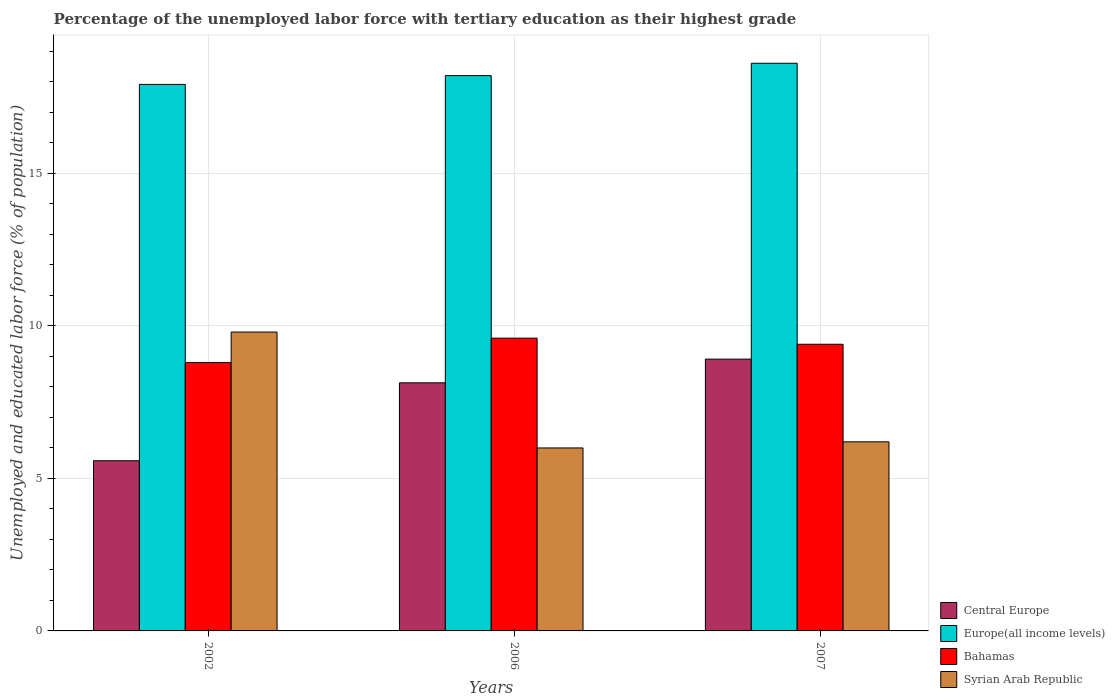How many groups of bars are there?
Offer a very short reply. 3. Are the number of bars on each tick of the X-axis equal?
Your answer should be very brief. Yes. How many bars are there on the 2nd tick from the left?
Your response must be concise. 4. What is the label of the 3rd group of bars from the left?
Provide a short and direct response. 2007. In how many cases, is the number of bars for a given year not equal to the number of legend labels?
Offer a terse response. 0. What is the percentage of the unemployed labor force with tertiary education in Syrian Arab Republic in 2002?
Your response must be concise. 9.8. Across all years, what is the maximum percentage of the unemployed labor force with tertiary education in Central Europe?
Give a very brief answer. 8.91. Across all years, what is the minimum percentage of the unemployed labor force with tertiary education in Central Europe?
Your response must be concise. 5.58. In which year was the percentage of the unemployed labor force with tertiary education in Bahamas maximum?
Provide a short and direct response. 2006. What is the total percentage of the unemployed labor force with tertiary education in Bahamas in the graph?
Provide a succinct answer. 27.8. What is the difference between the percentage of the unemployed labor force with tertiary education in Syrian Arab Republic in 2002 and that in 2007?
Ensure brevity in your answer.  3.6. What is the difference between the percentage of the unemployed labor force with tertiary education in Central Europe in 2006 and the percentage of the unemployed labor force with tertiary education in Europe(all income levels) in 2002?
Give a very brief answer. -9.78. What is the average percentage of the unemployed labor force with tertiary education in Central Europe per year?
Give a very brief answer. 7.54. In the year 2007, what is the difference between the percentage of the unemployed labor force with tertiary education in Europe(all income levels) and percentage of the unemployed labor force with tertiary education in Bahamas?
Your answer should be very brief. 9.21. What is the ratio of the percentage of the unemployed labor force with tertiary education in Central Europe in 2002 to that in 2006?
Your answer should be very brief. 0.69. Is the difference between the percentage of the unemployed labor force with tertiary education in Europe(all income levels) in 2002 and 2006 greater than the difference between the percentage of the unemployed labor force with tertiary education in Bahamas in 2002 and 2006?
Offer a terse response. Yes. What is the difference between the highest and the second highest percentage of the unemployed labor force with tertiary education in Europe(all income levels)?
Keep it short and to the point. 0.41. What is the difference between the highest and the lowest percentage of the unemployed labor force with tertiary education in Europe(all income levels)?
Make the answer very short. 0.69. What does the 2nd bar from the left in 2007 represents?
Your answer should be very brief. Europe(all income levels). What does the 1st bar from the right in 2002 represents?
Ensure brevity in your answer.  Syrian Arab Republic. Is it the case that in every year, the sum of the percentage of the unemployed labor force with tertiary education in Syrian Arab Republic and percentage of the unemployed labor force with tertiary education in Europe(all income levels) is greater than the percentage of the unemployed labor force with tertiary education in Bahamas?
Give a very brief answer. Yes. How many years are there in the graph?
Offer a very short reply. 3. What is the title of the graph?
Provide a succinct answer. Percentage of the unemployed labor force with tertiary education as their highest grade. Does "North America" appear as one of the legend labels in the graph?
Offer a very short reply. No. What is the label or title of the Y-axis?
Keep it short and to the point. Unemployed and educated labor force (% of population). What is the Unemployed and educated labor force (% of population) of Central Europe in 2002?
Your answer should be very brief. 5.58. What is the Unemployed and educated labor force (% of population) in Europe(all income levels) in 2002?
Give a very brief answer. 17.92. What is the Unemployed and educated labor force (% of population) of Bahamas in 2002?
Make the answer very short. 8.8. What is the Unemployed and educated labor force (% of population) of Syrian Arab Republic in 2002?
Offer a very short reply. 9.8. What is the Unemployed and educated labor force (% of population) of Central Europe in 2006?
Your response must be concise. 8.14. What is the Unemployed and educated labor force (% of population) of Europe(all income levels) in 2006?
Make the answer very short. 18.21. What is the Unemployed and educated labor force (% of population) in Bahamas in 2006?
Offer a terse response. 9.6. What is the Unemployed and educated labor force (% of population) of Syrian Arab Republic in 2006?
Give a very brief answer. 6. What is the Unemployed and educated labor force (% of population) in Central Europe in 2007?
Your answer should be compact. 8.91. What is the Unemployed and educated labor force (% of population) in Europe(all income levels) in 2007?
Make the answer very short. 18.61. What is the Unemployed and educated labor force (% of population) of Bahamas in 2007?
Give a very brief answer. 9.4. What is the Unemployed and educated labor force (% of population) of Syrian Arab Republic in 2007?
Give a very brief answer. 6.2. Across all years, what is the maximum Unemployed and educated labor force (% of population) in Central Europe?
Ensure brevity in your answer.  8.91. Across all years, what is the maximum Unemployed and educated labor force (% of population) of Europe(all income levels)?
Your answer should be compact. 18.61. Across all years, what is the maximum Unemployed and educated labor force (% of population) of Bahamas?
Make the answer very short. 9.6. Across all years, what is the maximum Unemployed and educated labor force (% of population) of Syrian Arab Republic?
Provide a short and direct response. 9.8. Across all years, what is the minimum Unemployed and educated labor force (% of population) in Central Europe?
Keep it short and to the point. 5.58. Across all years, what is the minimum Unemployed and educated labor force (% of population) in Europe(all income levels)?
Offer a very short reply. 17.92. Across all years, what is the minimum Unemployed and educated labor force (% of population) in Bahamas?
Your answer should be compact. 8.8. Across all years, what is the minimum Unemployed and educated labor force (% of population) in Syrian Arab Republic?
Offer a very short reply. 6. What is the total Unemployed and educated labor force (% of population) in Central Europe in the graph?
Offer a very short reply. 22.63. What is the total Unemployed and educated labor force (% of population) of Europe(all income levels) in the graph?
Make the answer very short. 54.74. What is the total Unemployed and educated labor force (% of population) of Bahamas in the graph?
Your response must be concise. 27.8. What is the difference between the Unemployed and educated labor force (% of population) of Central Europe in 2002 and that in 2006?
Provide a succinct answer. -2.56. What is the difference between the Unemployed and educated labor force (% of population) of Europe(all income levels) in 2002 and that in 2006?
Your answer should be compact. -0.29. What is the difference between the Unemployed and educated labor force (% of population) of Syrian Arab Republic in 2002 and that in 2006?
Give a very brief answer. 3.8. What is the difference between the Unemployed and educated labor force (% of population) in Central Europe in 2002 and that in 2007?
Provide a short and direct response. -3.33. What is the difference between the Unemployed and educated labor force (% of population) in Europe(all income levels) in 2002 and that in 2007?
Your response must be concise. -0.69. What is the difference between the Unemployed and educated labor force (% of population) of Syrian Arab Republic in 2002 and that in 2007?
Offer a very short reply. 3.6. What is the difference between the Unemployed and educated labor force (% of population) of Central Europe in 2006 and that in 2007?
Make the answer very short. -0.78. What is the difference between the Unemployed and educated labor force (% of population) in Europe(all income levels) in 2006 and that in 2007?
Your response must be concise. -0.41. What is the difference between the Unemployed and educated labor force (% of population) of Central Europe in 2002 and the Unemployed and educated labor force (% of population) of Europe(all income levels) in 2006?
Offer a very short reply. -12.63. What is the difference between the Unemployed and educated labor force (% of population) of Central Europe in 2002 and the Unemployed and educated labor force (% of population) of Bahamas in 2006?
Your response must be concise. -4.02. What is the difference between the Unemployed and educated labor force (% of population) in Central Europe in 2002 and the Unemployed and educated labor force (% of population) in Syrian Arab Republic in 2006?
Offer a terse response. -0.42. What is the difference between the Unemployed and educated labor force (% of population) in Europe(all income levels) in 2002 and the Unemployed and educated labor force (% of population) in Bahamas in 2006?
Provide a succinct answer. 8.32. What is the difference between the Unemployed and educated labor force (% of population) in Europe(all income levels) in 2002 and the Unemployed and educated labor force (% of population) in Syrian Arab Republic in 2006?
Keep it short and to the point. 11.92. What is the difference between the Unemployed and educated labor force (% of population) of Bahamas in 2002 and the Unemployed and educated labor force (% of population) of Syrian Arab Republic in 2006?
Offer a very short reply. 2.8. What is the difference between the Unemployed and educated labor force (% of population) in Central Europe in 2002 and the Unemployed and educated labor force (% of population) in Europe(all income levels) in 2007?
Make the answer very short. -13.03. What is the difference between the Unemployed and educated labor force (% of population) of Central Europe in 2002 and the Unemployed and educated labor force (% of population) of Bahamas in 2007?
Your response must be concise. -3.82. What is the difference between the Unemployed and educated labor force (% of population) in Central Europe in 2002 and the Unemployed and educated labor force (% of population) in Syrian Arab Republic in 2007?
Provide a short and direct response. -0.62. What is the difference between the Unemployed and educated labor force (% of population) in Europe(all income levels) in 2002 and the Unemployed and educated labor force (% of population) in Bahamas in 2007?
Keep it short and to the point. 8.52. What is the difference between the Unemployed and educated labor force (% of population) in Europe(all income levels) in 2002 and the Unemployed and educated labor force (% of population) in Syrian Arab Republic in 2007?
Your response must be concise. 11.72. What is the difference between the Unemployed and educated labor force (% of population) of Bahamas in 2002 and the Unemployed and educated labor force (% of population) of Syrian Arab Republic in 2007?
Your answer should be compact. 2.6. What is the difference between the Unemployed and educated labor force (% of population) in Central Europe in 2006 and the Unemployed and educated labor force (% of population) in Europe(all income levels) in 2007?
Your response must be concise. -10.48. What is the difference between the Unemployed and educated labor force (% of population) in Central Europe in 2006 and the Unemployed and educated labor force (% of population) in Bahamas in 2007?
Your answer should be very brief. -1.26. What is the difference between the Unemployed and educated labor force (% of population) of Central Europe in 2006 and the Unemployed and educated labor force (% of population) of Syrian Arab Republic in 2007?
Keep it short and to the point. 1.94. What is the difference between the Unemployed and educated labor force (% of population) of Europe(all income levels) in 2006 and the Unemployed and educated labor force (% of population) of Bahamas in 2007?
Your answer should be very brief. 8.81. What is the difference between the Unemployed and educated labor force (% of population) in Europe(all income levels) in 2006 and the Unemployed and educated labor force (% of population) in Syrian Arab Republic in 2007?
Make the answer very short. 12.01. What is the difference between the Unemployed and educated labor force (% of population) of Bahamas in 2006 and the Unemployed and educated labor force (% of population) of Syrian Arab Republic in 2007?
Offer a very short reply. 3.4. What is the average Unemployed and educated labor force (% of population) in Central Europe per year?
Give a very brief answer. 7.54. What is the average Unemployed and educated labor force (% of population) in Europe(all income levels) per year?
Your response must be concise. 18.25. What is the average Unemployed and educated labor force (% of population) in Bahamas per year?
Your answer should be compact. 9.27. What is the average Unemployed and educated labor force (% of population) of Syrian Arab Republic per year?
Your answer should be compact. 7.33. In the year 2002, what is the difference between the Unemployed and educated labor force (% of population) in Central Europe and Unemployed and educated labor force (% of population) in Europe(all income levels)?
Offer a very short reply. -12.34. In the year 2002, what is the difference between the Unemployed and educated labor force (% of population) in Central Europe and Unemployed and educated labor force (% of population) in Bahamas?
Your answer should be very brief. -3.22. In the year 2002, what is the difference between the Unemployed and educated labor force (% of population) in Central Europe and Unemployed and educated labor force (% of population) in Syrian Arab Republic?
Ensure brevity in your answer.  -4.22. In the year 2002, what is the difference between the Unemployed and educated labor force (% of population) in Europe(all income levels) and Unemployed and educated labor force (% of population) in Bahamas?
Ensure brevity in your answer.  9.12. In the year 2002, what is the difference between the Unemployed and educated labor force (% of population) of Europe(all income levels) and Unemployed and educated labor force (% of population) of Syrian Arab Republic?
Ensure brevity in your answer.  8.12. In the year 2006, what is the difference between the Unemployed and educated labor force (% of population) of Central Europe and Unemployed and educated labor force (% of population) of Europe(all income levels)?
Give a very brief answer. -10.07. In the year 2006, what is the difference between the Unemployed and educated labor force (% of population) in Central Europe and Unemployed and educated labor force (% of population) in Bahamas?
Make the answer very short. -1.46. In the year 2006, what is the difference between the Unemployed and educated labor force (% of population) in Central Europe and Unemployed and educated labor force (% of population) in Syrian Arab Republic?
Provide a short and direct response. 2.14. In the year 2006, what is the difference between the Unemployed and educated labor force (% of population) in Europe(all income levels) and Unemployed and educated labor force (% of population) in Bahamas?
Provide a short and direct response. 8.61. In the year 2006, what is the difference between the Unemployed and educated labor force (% of population) in Europe(all income levels) and Unemployed and educated labor force (% of population) in Syrian Arab Republic?
Give a very brief answer. 12.21. In the year 2007, what is the difference between the Unemployed and educated labor force (% of population) of Central Europe and Unemployed and educated labor force (% of population) of Europe(all income levels)?
Provide a short and direct response. -9.7. In the year 2007, what is the difference between the Unemployed and educated labor force (% of population) of Central Europe and Unemployed and educated labor force (% of population) of Bahamas?
Offer a very short reply. -0.49. In the year 2007, what is the difference between the Unemployed and educated labor force (% of population) in Central Europe and Unemployed and educated labor force (% of population) in Syrian Arab Republic?
Your answer should be very brief. 2.71. In the year 2007, what is the difference between the Unemployed and educated labor force (% of population) in Europe(all income levels) and Unemployed and educated labor force (% of population) in Bahamas?
Ensure brevity in your answer.  9.21. In the year 2007, what is the difference between the Unemployed and educated labor force (% of population) in Europe(all income levels) and Unemployed and educated labor force (% of population) in Syrian Arab Republic?
Ensure brevity in your answer.  12.41. In the year 2007, what is the difference between the Unemployed and educated labor force (% of population) of Bahamas and Unemployed and educated labor force (% of population) of Syrian Arab Republic?
Ensure brevity in your answer.  3.2. What is the ratio of the Unemployed and educated labor force (% of population) of Central Europe in 2002 to that in 2006?
Your response must be concise. 0.69. What is the ratio of the Unemployed and educated labor force (% of population) of Europe(all income levels) in 2002 to that in 2006?
Offer a very short reply. 0.98. What is the ratio of the Unemployed and educated labor force (% of population) of Syrian Arab Republic in 2002 to that in 2006?
Ensure brevity in your answer.  1.63. What is the ratio of the Unemployed and educated labor force (% of population) in Central Europe in 2002 to that in 2007?
Keep it short and to the point. 0.63. What is the ratio of the Unemployed and educated labor force (% of population) of Europe(all income levels) in 2002 to that in 2007?
Provide a short and direct response. 0.96. What is the ratio of the Unemployed and educated labor force (% of population) of Bahamas in 2002 to that in 2007?
Provide a short and direct response. 0.94. What is the ratio of the Unemployed and educated labor force (% of population) of Syrian Arab Republic in 2002 to that in 2007?
Your response must be concise. 1.58. What is the ratio of the Unemployed and educated labor force (% of population) of Central Europe in 2006 to that in 2007?
Provide a succinct answer. 0.91. What is the ratio of the Unemployed and educated labor force (% of population) in Europe(all income levels) in 2006 to that in 2007?
Keep it short and to the point. 0.98. What is the ratio of the Unemployed and educated labor force (% of population) of Bahamas in 2006 to that in 2007?
Provide a short and direct response. 1.02. What is the ratio of the Unemployed and educated labor force (% of population) of Syrian Arab Republic in 2006 to that in 2007?
Provide a succinct answer. 0.97. What is the difference between the highest and the second highest Unemployed and educated labor force (% of population) of Central Europe?
Your answer should be compact. 0.78. What is the difference between the highest and the second highest Unemployed and educated labor force (% of population) in Europe(all income levels)?
Ensure brevity in your answer.  0.41. What is the difference between the highest and the lowest Unemployed and educated labor force (% of population) of Central Europe?
Your response must be concise. 3.33. What is the difference between the highest and the lowest Unemployed and educated labor force (% of population) of Europe(all income levels)?
Ensure brevity in your answer.  0.69. 